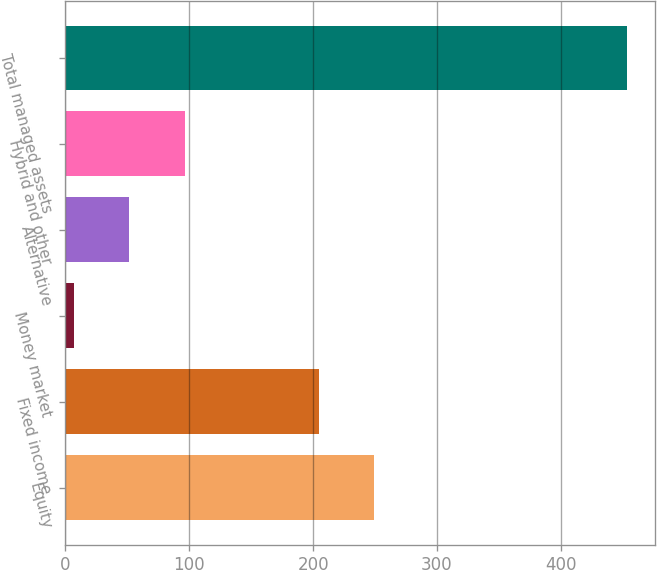Convert chart to OTSL. <chart><loc_0><loc_0><loc_500><loc_500><bar_chart><fcel>Equity<fcel>Fixed income<fcel>Money market<fcel>Alternative<fcel>Hybrid and other<fcel>Total managed assets<nl><fcel>249.53<fcel>204.9<fcel>7<fcel>51.63<fcel>96.26<fcel>453.3<nl></chart> 